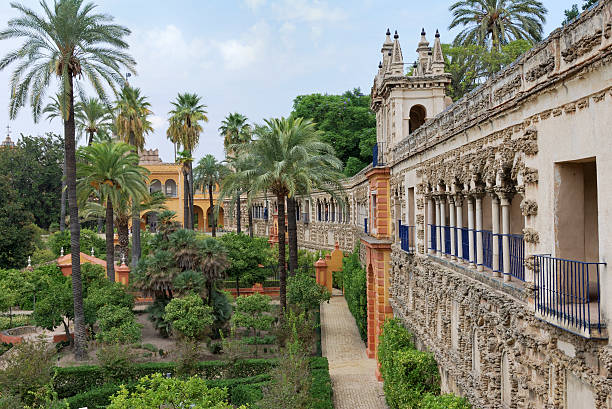What types of plants are predominantly seen in this garden? The gardens predominantly feature a variety of palm trees, which add a distinct tropical feel to the landscape. Alongside these towering palms, you can spot neatly trimmed hedges and bushes, and various flowering plants that add splashes of color. The plant selection is carefully curated to maintain a balance of formality and lushness, typical of historic royal gardens. This diverse collection not only enhances the aesthetic appeal but also contributes to the ecological diversity, supporting various local and migratory bird species. 